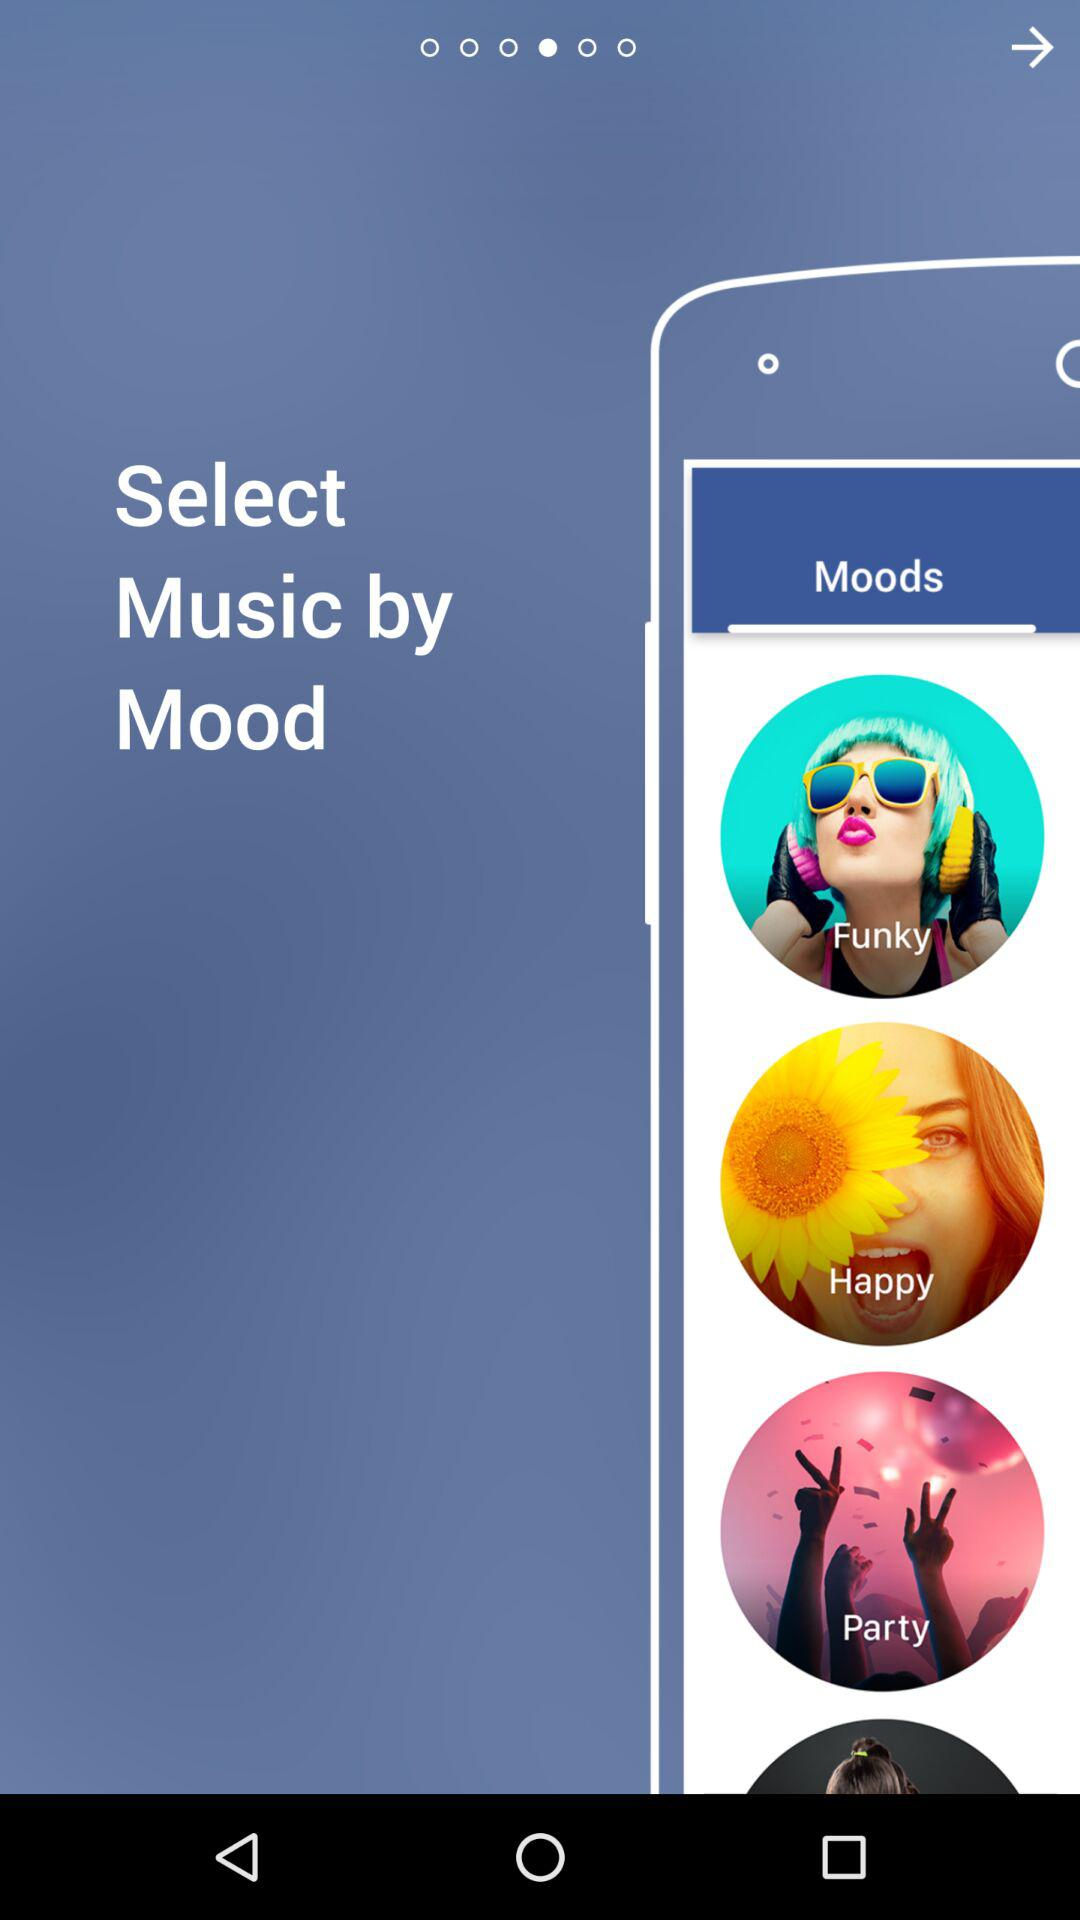How many moods are available to select?
Answer the question using a single word or phrase. 4 